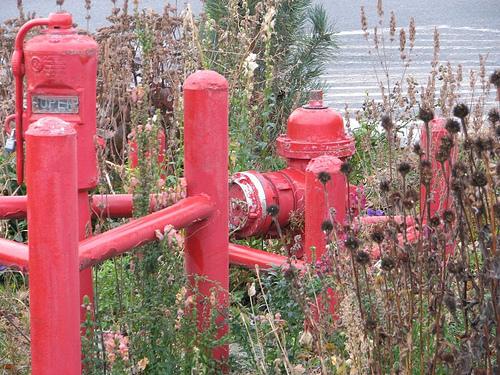Do you see any water?
Quick response, please. Yes. Has the grass been mowed recently?
Quick response, please. No. What color are the pipes?
Short answer required. Red. Is there water in the picture?
Write a very short answer. Yes. 